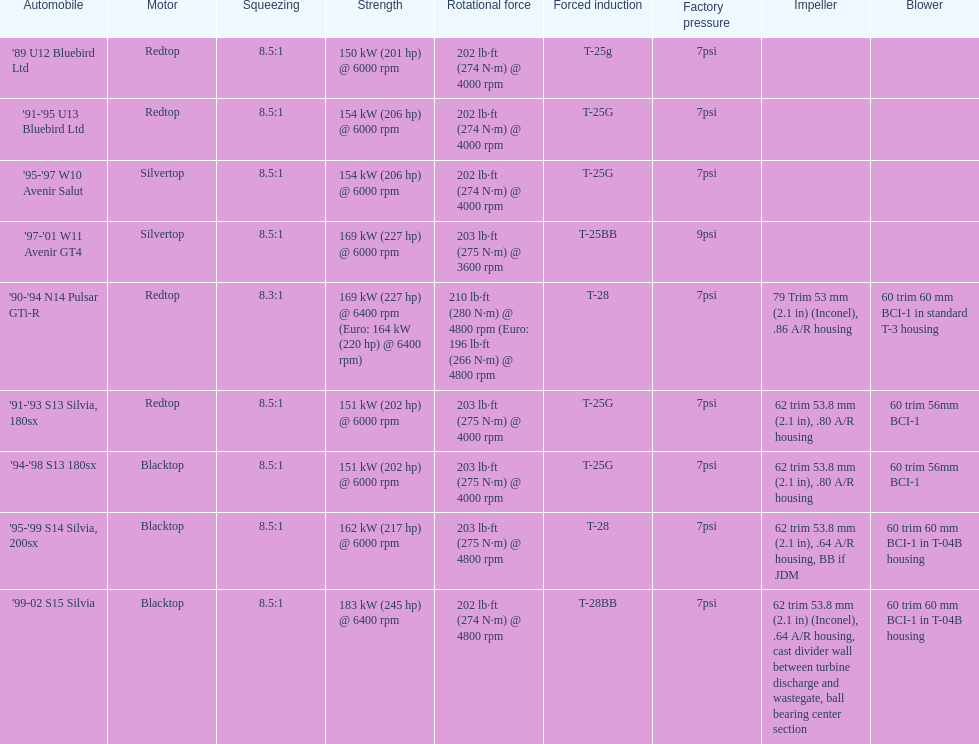Which car's power measured at higher than 6000 rpm? '90-'94 N14 Pulsar GTi-R, '99-02 S15 Silvia. 